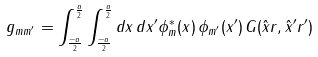Convert formula to latex. <formula><loc_0><loc_0><loc_500><loc_500>g _ { m m ^ { \prime } } = \int _ { \frac { - a } { 2 } } ^ { \frac { a } { 2 } } \int _ { \frac { - a } { 2 } } ^ { \frac { a } { 2 } } d x \, d x ^ { \prime } \phi _ { m } ^ { * } ( x ) \, \phi _ { m ^ { \prime } } ( x ^ { \prime } ) \, G ( { \hat { x } r } , { \hat { x } ^ { \prime } r ^ { \prime } } )</formula> 